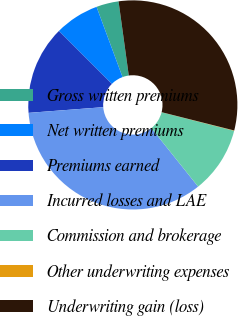Convert chart to OTSL. <chart><loc_0><loc_0><loc_500><loc_500><pie_chart><fcel>Gross written premiums<fcel>Net written premiums<fcel>Premiums earned<fcel>Incurred losses and LAE<fcel>Commission and brokerage<fcel>Other underwriting expenses<fcel>Underwriting gain (loss)<nl><fcel>3.46%<fcel>6.87%<fcel>13.7%<fcel>34.52%<fcel>10.29%<fcel>0.05%<fcel>31.11%<nl></chart> 